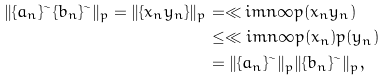Convert formula to latex. <formula><loc_0><loc_0><loc_500><loc_500>\| \{ a _ { n } \} ^ { \sim } \{ b _ { n } \} ^ { \sim } \| _ { p } = \| \{ x _ { n } y _ { n } \} \| _ { p } & = \ll i m { n } { \infty } p ( x _ { n } y _ { n } ) \\ & \leq \ll i m { n } { \infty } p ( x _ { n } ) p ( y _ { n } ) \\ & = \| \{ a _ { n } \} ^ { \sim } \| _ { p } \| \{ b _ { n } \} ^ { \sim } \| _ { p } ,</formula> 